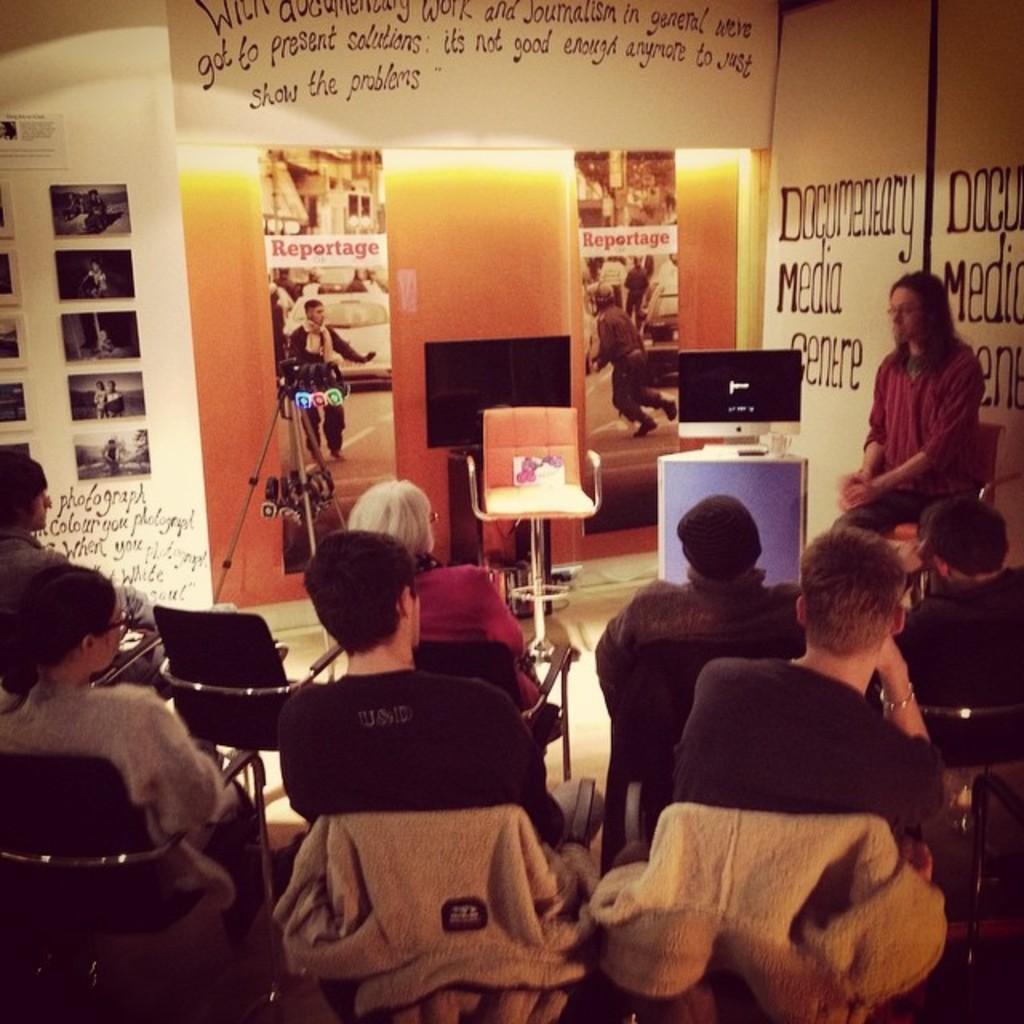Could you give a brief overview of what you see in this image? In this image there are few persons sitting on chairs, in front of them there is a person sitting on chair and there is a monitor on a table, in the background there is a wall on that wall there are posters and text and there is a camera stand. 